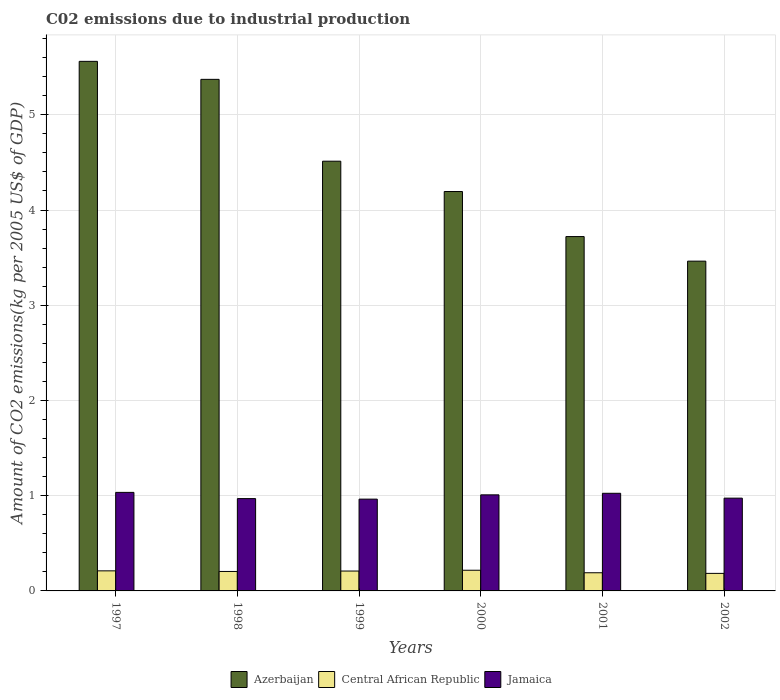Are the number of bars per tick equal to the number of legend labels?
Make the answer very short. Yes. How many bars are there on the 1st tick from the right?
Give a very brief answer. 3. What is the label of the 2nd group of bars from the left?
Offer a terse response. 1998. What is the amount of CO2 emitted due to industrial production in Central African Republic in 2000?
Your response must be concise. 0.22. Across all years, what is the maximum amount of CO2 emitted due to industrial production in Azerbaijan?
Give a very brief answer. 5.56. Across all years, what is the minimum amount of CO2 emitted due to industrial production in Jamaica?
Your response must be concise. 0.96. What is the total amount of CO2 emitted due to industrial production in Central African Republic in the graph?
Your response must be concise. 1.22. What is the difference between the amount of CO2 emitted due to industrial production in Jamaica in 2001 and that in 2002?
Make the answer very short. 0.05. What is the difference between the amount of CO2 emitted due to industrial production in Jamaica in 2002 and the amount of CO2 emitted due to industrial production in Central African Republic in 1999?
Provide a succinct answer. 0.77. What is the average amount of CO2 emitted due to industrial production in Central African Republic per year?
Provide a short and direct response. 0.2. In the year 1998, what is the difference between the amount of CO2 emitted due to industrial production in Central African Republic and amount of CO2 emitted due to industrial production in Azerbaijan?
Your answer should be very brief. -5.17. What is the ratio of the amount of CO2 emitted due to industrial production in Jamaica in 1997 to that in 2002?
Your answer should be compact. 1.06. Is the difference between the amount of CO2 emitted due to industrial production in Central African Republic in 2000 and 2002 greater than the difference between the amount of CO2 emitted due to industrial production in Azerbaijan in 2000 and 2002?
Provide a succinct answer. No. What is the difference between the highest and the second highest amount of CO2 emitted due to industrial production in Central African Republic?
Your answer should be very brief. 0.01. What is the difference between the highest and the lowest amount of CO2 emitted due to industrial production in Azerbaijan?
Give a very brief answer. 2.1. Is the sum of the amount of CO2 emitted due to industrial production in Jamaica in 1998 and 1999 greater than the maximum amount of CO2 emitted due to industrial production in Central African Republic across all years?
Your answer should be very brief. Yes. What does the 2nd bar from the left in 2002 represents?
Ensure brevity in your answer.  Central African Republic. What does the 3rd bar from the right in 2001 represents?
Provide a short and direct response. Azerbaijan. How many bars are there?
Your answer should be very brief. 18. Are all the bars in the graph horizontal?
Your answer should be very brief. No. What is the difference between two consecutive major ticks on the Y-axis?
Provide a succinct answer. 1. Are the values on the major ticks of Y-axis written in scientific E-notation?
Give a very brief answer. No. Does the graph contain grids?
Make the answer very short. Yes. Where does the legend appear in the graph?
Give a very brief answer. Bottom center. What is the title of the graph?
Your answer should be compact. C02 emissions due to industrial production. What is the label or title of the Y-axis?
Give a very brief answer. Amount of CO2 emissions(kg per 2005 US$ of GDP). What is the Amount of CO2 emissions(kg per 2005 US$ of GDP) of Azerbaijan in 1997?
Keep it short and to the point. 5.56. What is the Amount of CO2 emissions(kg per 2005 US$ of GDP) of Central African Republic in 1997?
Give a very brief answer. 0.21. What is the Amount of CO2 emissions(kg per 2005 US$ of GDP) in Jamaica in 1997?
Provide a succinct answer. 1.03. What is the Amount of CO2 emissions(kg per 2005 US$ of GDP) of Azerbaijan in 1998?
Provide a short and direct response. 5.37. What is the Amount of CO2 emissions(kg per 2005 US$ of GDP) in Central African Republic in 1998?
Keep it short and to the point. 0.2. What is the Amount of CO2 emissions(kg per 2005 US$ of GDP) of Jamaica in 1998?
Give a very brief answer. 0.97. What is the Amount of CO2 emissions(kg per 2005 US$ of GDP) of Azerbaijan in 1999?
Make the answer very short. 4.51. What is the Amount of CO2 emissions(kg per 2005 US$ of GDP) in Central African Republic in 1999?
Your response must be concise. 0.21. What is the Amount of CO2 emissions(kg per 2005 US$ of GDP) in Jamaica in 1999?
Make the answer very short. 0.96. What is the Amount of CO2 emissions(kg per 2005 US$ of GDP) in Azerbaijan in 2000?
Provide a succinct answer. 4.19. What is the Amount of CO2 emissions(kg per 2005 US$ of GDP) in Central African Republic in 2000?
Your answer should be compact. 0.22. What is the Amount of CO2 emissions(kg per 2005 US$ of GDP) in Jamaica in 2000?
Offer a very short reply. 1.01. What is the Amount of CO2 emissions(kg per 2005 US$ of GDP) in Azerbaijan in 2001?
Offer a terse response. 3.72. What is the Amount of CO2 emissions(kg per 2005 US$ of GDP) of Central African Republic in 2001?
Make the answer very short. 0.19. What is the Amount of CO2 emissions(kg per 2005 US$ of GDP) in Jamaica in 2001?
Provide a short and direct response. 1.03. What is the Amount of CO2 emissions(kg per 2005 US$ of GDP) in Azerbaijan in 2002?
Give a very brief answer. 3.46. What is the Amount of CO2 emissions(kg per 2005 US$ of GDP) in Central African Republic in 2002?
Your response must be concise. 0.18. What is the Amount of CO2 emissions(kg per 2005 US$ of GDP) in Jamaica in 2002?
Provide a succinct answer. 0.97. Across all years, what is the maximum Amount of CO2 emissions(kg per 2005 US$ of GDP) of Azerbaijan?
Your response must be concise. 5.56. Across all years, what is the maximum Amount of CO2 emissions(kg per 2005 US$ of GDP) in Central African Republic?
Ensure brevity in your answer.  0.22. Across all years, what is the maximum Amount of CO2 emissions(kg per 2005 US$ of GDP) of Jamaica?
Your answer should be very brief. 1.03. Across all years, what is the minimum Amount of CO2 emissions(kg per 2005 US$ of GDP) of Azerbaijan?
Offer a terse response. 3.46. Across all years, what is the minimum Amount of CO2 emissions(kg per 2005 US$ of GDP) in Central African Republic?
Ensure brevity in your answer.  0.18. Across all years, what is the minimum Amount of CO2 emissions(kg per 2005 US$ of GDP) of Jamaica?
Your answer should be compact. 0.96. What is the total Amount of CO2 emissions(kg per 2005 US$ of GDP) in Azerbaijan in the graph?
Your response must be concise. 26.83. What is the total Amount of CO2 emissions(kg per 2005 US$ of GDP) in Central African Republic in the graph?
Your response must be concise. 1.22. What is the total Amount of CO2 emissions(kg per 2005 US$ of GDP) of Jamaica in the graph?
Your response must be concise. 5.98. What is the difference between the Amount of CO2 emissions(kg per 2005 US$ of GDP) in Azerbaijan in 1997 and that in 1998?
Make the answer very short. 0.19. What is the difference between the Amount of CO2 emissions(kg per 2005 US$ of GDP) of Central African Republic in 1997 and that in 1998?
Provide a short and direct response. 0.01. What is the difference between the Amount of CO2 emissions(kg per 2005 US$ of GDP) in Jamaica in 1997 and that in 1998?
Offer a very short reply. 0.07. What is the difference between the Amount of CO2 emissions(kg per 2005 US$ of GDP) in Azerbaijan in 1997 and that in 1999?
Provide a succinct answer. 1.05. What is the difference between the Amount of CO2 emissions(kg per 2005 US$ of GDP) in Central African Republic in 1997 and that in 1999?
Make the answer very short. 0. What is the difference between the Amount of CO2 emissions(kg per 2005 US$ of GDP) in Jamaica in 1997 and that in 1999?
Keep it short and to the point. 0.07. What is the difference between the Amount of CO2 emissions(kg per 2005 US$ of GDP) of Azerbaijan in 1997 and that in 2000?
Make the answer very short. 1.37. What is the difference between the Amount of CO2 emissions(kg per 2005 US$ of GDP) in Central African Republic in 1997 and that in 2000?
Provide a succinct answer. -0.01. What is the difference between the Amount of CO2 emissions(kg per 2005 US$ of GDP) of Jamaica in 1997 and that in 2000?
Your answer should be compact. 0.03. What is the difference between the Amount of CO2 emissions(kg per 2005 US$ of GDP) in Azerbaijan in 1997 and that in 2001?
Ensure brevity in your answer.  1.84. What is the difference between the Amount of CO2 emissions(kg per 2005 US$ of GDP) of Jamaica in 1997 and that in 2001?
Ensure brevity in your answer.  0.01. What is the difference between the Amount of CO2 emissions(kg per 2005 US$ of GDP) in Azerbaijan in 1997 and that in 2002?
Your answer should be compact. 2.1. What is the difference between the Amount of CO2 emissions(kg per 2005 US$ of GDP) in Central African Republic in 1997 and that in 2002?
Make the answer very short. 0.03. What is the difference between the Amount of CO2 emissions(kg per 2005 US$ of GDP) of Jamaica in 1997 and that in 2002?
Your answer should be compact. 0.06. What is the difference between the Amount of CO2 emissions(kg per 2005 US$ of GDP) in Azerbaijan in 1998 and that in 1999?
Offer a terse response. 0.86. What is the difference between the Amount of CO2 emissions(kg per 2005 US$ of GDP) of Central African Republic in 1998 and that in 1999?
Offer a very short reply. -0. What is the difference between the Amount of CO2 emissions(kg per 2005 US$ of GDP) in Jamaica in 1998 and that in 1999?
Offer a very short reply. 0.01. What is the difference between the Amount of CO2 emissions(kg per 2005 US$ of GDP) of Azerbaijan in 1998 and that in 2000?
Your response must be concise. 1.18. What is the difference between the Amount of CO2 emissions(kg per 2005 US$ of GDP) in Central African Republic in 1998 and that in 2000?
Your answer should be very brief. -0.01. What is the difference between the Amount of CO2 emissions(kg per 2005 US$ of GDP) in Jamaica in 1998 and that in 2000?
Keep it short and to the point. -0.04. What is the difference between the Amount of CO2 emissions(kg per 2005 US$ of GDP) in Azerbaijan in 1998 and that in 2001?
Provide a succinct answer. 1.65. What is the difference between the Amount of CO2 emissions(kg per 2005 US$ of GDP) of Central African Republic in 1998 and that in 2001?
Offer a very short reply. 0.01. What is the difference between the Amount of CO2 emissions(kg per 2005 US$ of GDP) in Jamaica in 1998 and that in 2001?
Ensure brevity in your answer.  -0.06. What is the difference between the Amount of CO2 emissions(kg per 2005 US$ of GDP) in Azerbaijan in 1998 and that in 2002?
Offer a very short reply. 1.91. What is the difference between the Amount of CO2 emissions(kg per 2005 US$ of GDP) of Central African Republic in 1998 and that in 2002?
Provide a succinct answer. 0.02. What is the difference between the Amount of CO2 emissions(kg per 2005 US$ of GDP) in Jamaica in 1998 and that in 2002?
Ensure brevity in your answer.  -0. What is the difference between the Amount of CO2 emissions(kg per 2005 US$ of GDP) of Azerbaijan in 1999 and that in 2000?
Ensure brevity in your answer.  0.32. What is the difference between the Amount of CO2 emissions(kg per 2005 US$ of GDP) in Central African Republic in 1999 and that in 2000?
Offer a terse response. -0.01. What is the difference between the Amount of CO2 emissions(kg per 2005 US$ of GDP) of Jamaica in 1999 and that in 2000?
Your response must be concise. -0.04. What is the difference between the Amount of CO2 emissions(kg per 2005 US$ of GDP) in Azerbaijan in 1999 and that in 2001?
Offer a very short reply. 0.79. What is the difference between the Amount of CO2 emissions(kg per 2005 US$ of GDP) of Central African Republic in 1999 and that in 2001?
Keep it short and to the point. 0.02. What is the difference between the Amount of CO2 emissions(kg per 2005 US$ of GDP) of Jamaica in 1999 and that in 2001?
Offer a very short reply. -0.06. What is the difference between the Amount of CO2 emissions(kg per 2005 US$ of GDP) in Azerbaijan in 1999 and that in 2002?
Keep it short and to the point. 1.05. What is the difference between the Amount of CO2 emissions(kg per 2005 US$ of GDP) in Central African Republic in 1999 and that in 2002?
Your answer should be compact. 0.02. What is the difference between the Amount of CO2 emissions(kg per 2005 US$ of GDP) in Jamaica in 1999 and that in 2002?
Offer a very short reply. -0.01. What is the difference between the Amount of CO2 emissions(kg per 2005 US$ of GDP) of Azerbaijan in 2000 and that in 2001?
Provide a succinct answer. 0.47. What is the difference between the Amount of CO2 emissions(kg per 2005 US$ of GDP) in Central African Republic in 2000 and that in 2001?
Give a very brief answer. 0.03. What is the difference between the Amount of CO2 emissions(kg per 2005 US$ of GDP) of Jamaica in 2000 and that in 2001?
Your answer should be very brief. -0.02. What is the difference between the Amount of CO2 emissions(kg per 2005 US$ of GDP) of Azerbaijan in 2000 and that in 2002?
Ensure brevity in your answer.  0.73. What is the difference between the Amount of CO2 emissions(kg per 2005 US$ of GDP) in Central African Republic in 2000 and that in 2002?
Your answer should be compact. 0.03. What is the difference between the Amount of CO2 emissions(kg per 2005 US$ of GDP) of Jamaica in 2000 and that in 2002?
Offer a terse response. 0.03. What is the difference between the Amount of CO2 emissions(kg per 2005 US$ of GDP) in Azerbaijan in 2001 and that in 2002?
Offer a terse response. 0.26. What is the difference between the Amount of CO2 emissions(kg per 2005 US$ of GDP) in Central African Republic in 2001 and that in 2002?
Keep it short and to the point. 0.01. What is the difference between the Amount of CO2 emissions(kg per 2005 US$ of GDP) of Jamaica in 2001 and that in 2002?
Make the answer very short. 0.05. What is the difference between the Amount of CO2 emissions(kg per 2005 US$ of GDP) in Azerbaijan in 1997 and the Amount of CO2 emissions(kg per 2005 US$ of GDP) in Central African Republic in 1998?
Your response must be concise. 5.36. What is the difference between the Amount of CO2 emissions(kg per 2005 US$ of GDP) in Azerbaijan in 1997 and the Amount of CO2 emissions(kg per 2005 US$ of GDP) in Jamaica in 1998?
Your answer should be very brief. 4.59. What is the difference between the Amount of CO2 emissions(kg per 2005 US$ of GDP) in Central African Republic in 1997 and the Amount of CO2 emissions(kg per 2005 US$ of GDP) in Jamaica in 1998?
Provide a short and direct response. -0.76. What is the difference between the Amount of CO2 emissions(kg per 2005 US$ of GDP) in Azerbaijan in 1997 and the Amount of CO2 emissions(kg per 2005 US$ of GDP) in Central African Republic in 1999?
Offer a terse response. 5.35. What is the difference between the Amount of CO2 emissions(kg per 2005 US$ of GDP) in Azerbaijan in 1997 and the Amount of CO2 emissions(kg per 2005 US$ of GDP) in Jamaica in 1999?
Provide a short and direct response. 4.6. What is the difference between the Amount of CO2 emissions(kg per 2005 US$ of GDP) in Central African Republic in 1997 and the Amount of CO2 emissions(kg per 2005 US$ of GDP) in Jamaica in 1999?
Keep it short and to the point. -0.75. What is the difference between the Amount of CO2 emissions(kg per 2005 US$ of GDP) of Azerbaijan in 1997 and the Amount of CO2 emissions(kg per 2005 US$ of GDP) of Central African Republic in 2000?
Make the answer very short. 5.34. What is the difference between the Amount of CO2 emissions(kg per 2005 US$ of GDP) of Azerbaijan in 1997 and the Amount of CO2 emissions(kg per 2005 US$ of GDP) of Jamaica in 2000?
Provide a succinct answer. 4.55. What is the difference between the Amount of CO2 emissions(kg per 2005 US$ of GDP) in Central African Republic in 1997 and the Amount of CO2 emissions(kg per 2005 US$ of GDP) in Jamaica in 2000?
Ensure brevity in your answer.  -0.8. What is the difference between the Amount of CO2 emissions(kg per 2005 US$ of GDP) of Azerbaijan in 1997 and the Amount of CO2 emissions(kg per 2005 US$ of GDP) of Central African Republic in 2001?
Provide a short and direct response. 5.37. What is the difference between the Amount of CO2 emissions(kg per 2005 US$ of GDP) of Azerbaijan in 1997 and the Amount of CO2 emissions(kg per 2005 US$ of GDP) of Jamaica in 2001?
Make the answer very short. 4.54. What is the difference between the Amount of CO2 emissions(kg per 2005 US$ of GDP) in Central African Republic in 1997 and the Amount of CO2 emissions(kg per 2005 US$ of GDP) in Jamaica in 2001?
Keep it short and to the point. -0.81. What is the difference between the Amount of CO2 emissions(kg per 2005 US$ of GDP) in Azerbaijan in 1997 and the Amount of CO2 emissions(kg per 2005 US$ of GDP) in Central African Republic in 2002?
Your answer should be compact. 5.38. What is the difference between the Amount of CO2 emissions(kg per 2005 US$ of GDP) in Azerbaijan in 1997 and the Amount of CO2 emissions(kg per 2005 US$ of GDP) in Jamaica in 2002?
Offer a very short reply. 4.59. What is the difference between the Amount of CO2 emissions(kg per 2005 US$ of GDP) in Central African Republic in 1997 and the Amount of CO2 emissions(kg per 2005 US$ of GDP) in Jamaica in 2002?
Your answer should be compact. -0.76. What is the difference between the Amount of CO2 emissions(kg per 2005 US$ of GDP) of Azerbaijan in 1998 and the Amount of CO2 emissions(kg per 2005 US$ of GDP) of Central African Republic in 1999?
Provide a short and direct response. 5.16. What is the difference between the Amount of CO2 emissions(kg per 2005 US$ of GDP) of Azerbaijan in 1998 and the Amount of CO2 emissions(kg per 2005 US$ of GDP) of Jamaica in 1999?
Offer a very short reply. 4.41. What is the difference between the Amount of CO2 emissions(kg per 2005 US$ of GDP) in Central African Republic in 1998 and the Amount of CO2 emissions(kg per 2005 US$ of GDP) in Jamaica in 1999?
Make the answer very short. -0.76. What is the difference between the Amount of CO2 emissions(kg per 2005 US$ of GDP) of Azerbaijan in 1998 and the Amount of CO2 emissions(kg per 2005 US$ of GDP) of Central African Republic in 2000?
Provide a short and direct response. 5.16. What is the difference between the Amount of CO2 emissions(kg per 2005 US$ of GDP) in Azerbaijan in 1998 and the Amount of CO2 emissions(kg per 2005 US$ of GDP) in Jamaica in 2000?
Your answer should be compact. 4.36. What is the difference between the Amount of CO2 emissions(kg per 2005 US$ of GDP) in Central African Republic in 1998 and the Amount of CO2 emissions(kg per 2005 US$ of GDP) in Jamaica in 2000?
Offer a terse response. -0.8. What is the difference between the Amount of CO2 emissions(kg per 2005 US$ of GDP) of Azerbaijan in 1998 and the Amount of CO2 emissions(kg per 2005 US$ of GDP) of Central African Republic in 2001?
Make the answer very short. 5.18. What is the difference between the Amount of CO2 emissions(kg per 2005 US$ of GDP) in Azerbaijan in 1998 and the Amount of CO2 emissions(kg per 2005 US$ of GDP) in Jamaica in 2001?
Your response must be concise. 4.35. What is the difference between the Amount of CO2 emissions(kg per 2005 US$ of GDP) of Central African Republic in 1998 and the Amount of CO2 emissions(kg per 2005 US$ of GDP) of Jamaica in 2001?
Give a very brief answer. -0.82. What is the difference between the Amount of CO2 emissions(kg per 2005 US$ of GDP) in Azerbaijan in 1998 and the Amount of CO2 emissions(kg per 2005 US$ of GDP) in Central African Republic in 2002?
Provide a short and direct response. 5.19. What is the difference between the Amount of CO2 emissions(kg per 2005 US$ of GDP) of Azerbaijan in 1998 and the Amount of CO2 emissions(kg per 2005 US$ of GDP) of Jamaica in 2002?
Keep it short and to the point. 4.4. What is the difference between the Amount of CO2 emissions(kg per 2005 US$ of GDP) of Central African Republic in 1998 and the Amount of CO2 emissions(kg per 2005 US$ of GDP) of Jamaica in 2002?
Offer a terse response. -0.77. What is the difference between the Amount of CO2 emissions(kg per 2005 US$ of GDP) of Azerbaijan in 1999 and the Amount of CO2 emissions(kg per 2005 US$ of GDP) of Central African Republic in 2000?
Your answer should be very brief. 4.3. What is the difference between the Amount of CO2 emissions(kg per 2005 US$ of GDP) in Azerbaijan in 1999 and the Amount of CO2 emissions(kg per 2005 US$ of GDP) in Jamaica in 2000?
Give a very brief answer. 3.5. What is the difference between the Amount of CO2 emissions(kg per 2005 US$ of GDP) of Central African Republic in 1999 and the Amount of CO2 emissions(kg per 2005 US$ of GDP) of Jamaica in 2000?
Offer a terse response. -0.8. What is the difference between the Amount of CO2 emissions(kg per 2005 US$ of GDP) in Azerbaijan in 1999 and the Amount of CO2 emissions(kg per 2005 US$ of GDP) in Central African Republic in 2001?
Your answer should be compact. 4.32. What is the difference between the Amount of CO2 emissions(kg per 2005 US$ of GDP) of Azerbaijan in 1999 and the Amount of CO2 emissions(kg per 2005 US$ of GDP) of Jamaica in 2001?
Provide a short and direct response. 3.49. What is the difference between the Amount of CO2 emissions(kg per 2005 US$ of GDP) in Central African Republic in 1999 and the Amount of CO2 emissions(kg per 2005 US$ of GDP) in Jamaica in 2001?
Keep it short and to the point. -0.82. What is the difference between the Amount of CO2 emissions(kg per 2005 US$ of GDP) in Azerbaijan in 1999 and the Amount of CO2 emissions(kg per 2005 US$ of GDP) in Central African Republic in 2002?
Keep it short and to the point. 4.33. What is the difference between the Amount of CO2 emissions(kg per 2005 US$ of GDP) of Azerbaijan in 1999 and the Amount of CO2 emissions(kg per 2005 US$ of GDP) of Jamaica in 2002?
Give a very brief answer. 3.54. What is the difference between the Amount of CO2 emissions(kg per 2005 US$ of GDP) in Central African Republic in 1999 and the Amount of CO2 emissions(kg per 2005 US$ of GDP) in Jamaica in 2002?
Keep it short and to the point. -0.77. What is the difference between the Amount of CO2 emissions(kg per 2005 US$ of GDP) of Azerbaijan in 2000 and the Amount of CO2 emissions(kg per 2005 US$ of GDP) of Central African Republic in 2001?
Make the answer very short. 4. What is the difference between the Amount of CO2 emissions(kg per 2005 US$ of GDP) of Azerbaijan in 2000 and the Amount of CO2 emissions(kg per 2005 US$ of GDP) of Jamaica in 2001?
Make the answer very short. 3.17. What is the difference between the Amount of CO2 emissions(kg per 2005 US$ of GDP) of Central African Republic in 2000 and the Amount of CO2 emissions(kg per 2005 US$ of GDP) of Jamaica in 2001?
Give a very brief answer. -0.81. What is the difference between the Amount of CO2 emissions(kg per 2005 US$ of GDP) of Azerbaijan in 2000 and the Amount of CO2 emissions(kg per 2005 US$ of GDP) of Central African Republic in 2002?
Your response must be concise. 4.01. What is the difference between the Amount of CO2 emissions(kg per 2005 US$ of GDP) in Azerbaijan in 2000 and the Amount of CO2 emissions(kg per 2005 US$ of GDP) in Jamaica in 2002?
Provide a succinct answer. 3.22. What is the difference between the Amount of CO2 emissions(kg per 2005 US$ of GDP) in Central African Republic in 2000 and the Amount of CO2 emissions(kg per 2005 US$ of GDP) in Jamaica in 2002?
Offer a terse response. -0.76. What is the difference between the Amount of CO2 emissions(kg per 2005 US$ of GDP) of Azerbaijan in 2001 and the Amount of CO2 emissions(kg per 2005 US$ of GDP) of Central African Republic in 2002?
Offer a very short reply. 3.54. What is the difference between the Amount of CO2 emissions(kg per 2005 US$ of GDP) of Azerbaijan in 2001 and the Amount of CO2 emissions(kg per 2005 US$ of GDP) of Jamaica in 2002?
Your answer should be compact. 2.75. What is the difference between the Amount of CO2 emissions(kg per 2005 US$ of GDP) of Central African Republic in 2001 and the Amount of CO2 emissions(kg per 2005 US$ of GDP) of Jamaica in 2002?
Your answer should be compact. -0.78. What is the average Amount of CO2 emissions(kg per 2005 US$ of GDP) of Azerbaijan per year?
Keep it short and to the point. 4.47. What is the average Amount of CO2 emissions(kg per 2005 US$ of GDP) of Central African Republic per year?
Your answer should be compact. 0.2. In the year 1997, what is the difference between the Amount of CO2 emissions(kg per 2005 US$ of GDP) of Azerbaijan and Amount of CO2 emissions(kg per 2005 US$ of GDP) of Central African Republic?
Provide a succinct answer. 5.35. In the year 1997, what is the difference between the Amount of CO2 emissions(kg per 2005 US$ of GDP) in Azerbaijan and Amount of CO2 emissions(kg per 2005 US$ of GDP) in Jamaica?
Your answer should be very brief. 4.53. In the year 1997, what is the difference between the Amount of CO2 emissions(kg per 2005 US$ of GDP) in Central African Republic and Amount of CO2 emissions(kg per 2005 US$ of GDP) in Jamaica?
Provide a short and direct response. -0.82. In the year 1998, what is the difference between the Amount of CO2 emissions(kg per 2005 US$ of GDP) in Azerbaijan and Amount of CO2 emissions(kg per 2005 US$ of GDP) in Central African Republic?
Give a very brief answer. 5.17. In the year 1998, what is the difference between the Amount of CO2 emissions(kg per 2005 US$ of GDP) in Azerbaijan and Amount of CO2 emissions(kg per 2005 US$ of GDP) in Jamaica?
Offer a very short reply. 4.4. In the year 1998, what is the difference between the Amount of CO2 emissions(kg per 2005 US$ of GDP) in Central African Republic and Amount of CO2 emissions(kg per 2005 US$ of GDP) in Jamaica?
Offer a terse response. -0.77. In the year 1999, what is the difference between the Amount of CO2 emissions(kg per 2005 US$ of GDP) in Azerbaijan and Amount of CO2 emissions(kg per 2005 US$ of GDP) in Central African Republic?
Ensure brevity in your answer.  4.3. In the year 1999, what is the difference between the Amount of CO2 emissions(kg per 2005 US$ of GDP) in Azerbaijan and Amount of CO2 emissions(kg per 2005 US$ of GDP) in Jamaica?
Your response must be concise. 3.55. In the year 1999, what is the difference between the Amount of CO2 emissions(kg per 2005 US$ of GDP) in Central African Republic and Amount of CO2 emissions(kg per 2005 US$ of GDP) in Jamaica?
Your answer should be very brief. -0.76. In the year 2000, what is the difference between the Amount of CO2 emissions(kg per 2005 US$ of GDP) of Azerbaijan and Amount of CO2 emissions(kg per 2005 US$ of GDP) of Central African Republic?
Ensure brevity in your answer.  3.98. In the year 2000, what is the difference between the Amount of CO2 emissions(kg per 2005 US$ of GDP) of Azerbaijan and Amount of CO2 emissions(kg per 2005 US$ of GDP) of Jamaica?
Make the answer very short. 3.19. In the year 2000, what is the difference between the Amount of CO2 emissions(kg per 2005 US$ of GDP) in Central African Republic and Amount of CO2 emissions(kg per 2005 US$ of GDP) in Jamaica?
Offer a very short reply. -0.79. In the year 2001, what is the difference between the Amount of CO2 emissions(kg per 2005 US$ of GDP) in Azerbaijan and Amount of CO2 emissions(kg per 2005 US$ of GDP) in Central African Republic?
Provide a short and direct response. 3.53. In the year 2001, what is the difference between the Amount of CO2 emissions(kg per 2005 US$ of GDP) of Azerbaijan and Amount of CO2 emissions(kg per 2005 US$ of GDP) of Jamaica?
Keep it short and to the point. 2.7. In the year 2001, what is the difference between the Amount of CO2 emissions(kg per 2005 US$ of GDP) in Central African Republic and Amount of CO2 emissions(kg per 2005 US$ of GDP) in Jamaica?
Your response must be concise. -0.83. In the year 2002, what is the difference between the Amount of CO2 emissions(kg per 2005 US$ of GDP) in Azerbaijan and Amount of CO2 emissions(kg per 2005 US$ of GDP) in Central African Republic?
Give a very brief answer. 3.28. In the year 2002, what is the difference between the Amount of CO2 emissions(kg per 2005 US$ of GDP) of Azerbaijan and Amount of CO2 emissions(kg per 2005 US$ of GDP) of Jamaica?
Provide a succinct answer. 2.49. In the year 2002, what is the difference between the Amount of CO2 emissions(kg per 2005 US$ of GDP) in Central African Republic and Amount of CO2 emissions(kg per 2005 US$ of GDP) in Jamaica?
Provide a short and direct response. -0.79. What is the ratio of the Amount of CO2 emissions(kg per 2005 US$ of GDP) of Azerbaijan in 1997 to that in 1998?
Provide a succinct answer. 1.04. What is the ratio of the Amount of CO2 emissions(kg per 2005 US$ of GDP) of Central African Republic in 1997 to that in 1998?
Ensure brevity in your answer.  1.03. What is the ratio of the Amount of CO2 emissions(kg per 2005 US$ of GDP) in Jamaica in 1997 to that in 1998?
Your answer should be very brief. 1.07. What is the ratio of the Amount of CO2 emissions(kg per 2005 US$ of GDP) of Azerbaijan in 1997 to that in 1999?
Make the answer very short. 1.23. What is the ratio of the Amount of CO2 emissions(kg per 2005 US$ of GDP) of Central African Republic in 1997 to that in 1999?
Ensure brevity in your answer.  1.01. What is the ratio of the Amount of CO2 emissions(kg per 2005 US$ of GDP) in Jamaica in 1997 to that in 1999?
Keep it short and to the point. 1.07. What is the ratio of the Amount of CO2 emissions(kg per 2005 US$ of GDP) of Azerbaijan in 1997 to that in 2000?
Your response must be concise. 1.33. What is the ratio of the Amount of CO2 emissions(kg per 2005 US$ of GDP) in Central African Republic in 1997 to that in 2000?
Provide a short and direct response. 0.97. What is the ratio of the Amount of CO2 emissions(kg per 2005 US$ of GDP) of Jamaica in 1997 to that in 2000?
Make the answer very short. 1.03. What is the ratio of the Amount of CO2 emissions(kg per 2005 US$ of GDP) of Azerbaijan in 1997 to that in 2001?
Your answer should be very brief. 1.49. What is the ratio of the Amount of CO2 emissions(kg per 2005 US$ of GDP) of Central African Republic in 1997 to that in 2001?
Provide a short and direct response. 1.1. What is the ratio of the Amount of CO2 emissions(kg per 2005 US$ of GDP) of Jamaica in 1997 to that in 2001?
Keep it short and to the point. 1.01. What is the ratio of the Amount of CO2 emissions(kg per 2005 US$ of GDP) of Azerbaijan in 1997 to that in 2002?
Offer a terse response. 1.61. What is the ratio of the Amount of CO2 emissions(kg per 2005 US$ of GDP) of Central African Republic in 1997 to that in 2002?
Offer a very short reply. 1.14. What is the ratio of the Amount of CO2 emissions(kg per 2005 US$ of GDP) of Jamaica in 1997 to that in 2002?
Your answer should be compact. 1.06. What is the ratio of the Amount of CO2 emissions(kg per 2005 US$ of GDP) of Azerbaijan in 1998 to that in 1999?
Your response must be concise. 1.19. What is the ratio of the Amount of CO2 emissions(kg per 2005 US$ of GDP) of Central African Republic in 1998 to that in 1999?
Provide a short and direct response. 0.98. What is the ratio of the Amount of CO2 emissions(kg per 2005 US$ of GDP) in Jamaica in 1998 to that in 1999?
Keep it short and to the point. 1.01. What is the ratio of the Amount of CO2 emissions(kg per 2005 US$ of GDP) of Azerbaijan in 1998 to that in 2000?
Provide a succinct answer. 1.28. What is the ratio of the Amount of CO2 emissions(kg per 2005 US$ of GDP) of Central African Republic in 1998 to that in 2000?
Offer a very short reply. 0.94. What is the ratio of the Amount of CO2 emissions(kg per 2005 US$ of GDP) in Azerbaijan in 1998 to that in 2001?
Keep it short and to the point. 1.44. What is the ratio of the Amount of CO2 emissions(kg per 2005 US$ of GDP) of Central African Republic in 1998 to that in 2001?
Make the answer very short. 1.07. What is the ratio of the Amount of CO2 emissions(kg per 2005 US$ of GDP) of Jamaica in 1998 to that in 2001?
Give a very brief answer. 0.95. What is the ratio of the Amount of CO2 emissions(kg per 2005 US$ of GDP) of Azerbaijan in 1998 to that in 2002?
Make the answer very short. 1.55. What is the ratio of the Amount of CO2 emissions(kg per 2005 US$ of GDP) of Central African Republic in 1998 to that in 2002?
Your answer should be very brief. 1.11. What is the ratio of the Amount of CO2 emissions(kg per 2005 US$ of GDP) in Azerbaijan in 1999 to that in 2000?
Your answer should be compact. 1.08. What is the ratio of the Amount of CO2 emissions(kg per 2005 US$ of GDP) in Central African Republic in 1999 to that in 2000?
Your answer should be compact. 0.96. What is the ratio of the Amount of CO2 emissions(kg per 2005 US$ of GDP) of Jamaica in 1999 to that in 2000?
Ensure brevity in your answer.  0.96. What is the ratio of the Amount of CO2 emissions(kg per 2005 US$ of GDP) of Azerbaijan in 1999 to that in 2001?
Provide a short and direct response. 1.21. What is the ratio of the Amount of CO2 emissions(kg per 2005 US$ of GDP) of Central African Republic in 1999 to that in 2001?
Your answer should be very brief. 1.09. What is the ratio of the Amount of CO2 emissions(kg per 2005 US$ of GDP) of Jamaica in 1999 to that in 2001?
Ensure brevity in your answer.  0.94. What is the ratio of the Amount of CO2 emissions(kg per 2005 US$ of GDP) in Azerbaijan in 1999 to that in 2002?
Keep it short and to the point. 1.3. What is the ratio of the Amount of CO2 emissions(kg per 2005 US$ of GDP) of Central African Republic in 1999 to that in 2002?
Ensure brevity in your answer.  1.13. What is the ratio of the Amount of CO2 emissions(kg per 2005 US$ of GDP) of Jamaica in 1999 to that in 2002?
Provide a succinct answer. 0.99. What is the ratio of the Amount of CO2 emissions(kg per 2005 US$ of GDP) in Azerbaijan in 2000 to that in 2001?
Make the answer very short. 1.13. What is the ratio of the Amount of CO2 emissions(kg per 2005 US$ of GDP) in Central African Republic in 2000 to that in 2001?
Provide a short and direct response. 1.14. What is the ratio of the Amount of CO2 emissions(kg per 2005 US$ of GDP) of Jamaica in 2000 to that in 2001?
Offer a terse response. 0.98. What is the ratio of the Amount of CO2 emissions(kg per 2005 US$ of GDP) of Azerbaijan in 2000 to that in 2002?
Make the answer very short. 1.21. What is the ratio of the Amount of CO2 emissions(kg per 2005 US$ of GDP) in Central African Republic in 2000 to that in 2002?
Offer a very short reply. 1.18. What is the ratio of the Amount of CO2 emissions(kg per 2005 US$ of GDP) in Jamaica in 2000 to that in 2002?
Your answer should be very brief. 1.04. What is the ratio of the Amount of CO2 emissions(kg per 2005 US$ of GDP) of Azerbaijan in 2001 to that in 2002?
Ensure brevity in your answer.  1.07. What is the ratio of the Amount of CO2 emissions(kg per 2005 US$ of GDP) in Central African Republic in 2001 to that in 2002?
Offer a terse response. 1.04. What is the ratio of the Amount of CO2 emissions(kg per 2005 US$ of GDP) of Jamaica in 2001 to that in 2002?
Offer a very short reply. 1.05. What is the difference between the highest and the second highest Amount of CO2 emissions(kg per 2005 US$ of GDP) of Azerbaijan?
Give a very brief answer. 0.19. What is the difference between the highest and the second highest Amount of CO2 emissions(kg per 2005 US$ of GDP) in Central African Republic?
Provide a succinct answer. 0.01. What is the difference between the highest and the second highest Amount of CO2 emissions(kg per 2005 US$ of GDP) in Jamaica?
Offer a terse response. 0.01. What is the difference between the highest and the lowest Amount of CO2 emissions(kg per 2005 US$ of GDP) of Azerbaijan?
Ensure brevity in your answer.  2.1. What is the difference between the highest and the lowest Amount of CO2 emissions(kg per 2005 US$ of GDP) of Central African Republic?
Your answer should be compact. 0.03. What is the difference between the highest and the lowest Amount of CO2 emissions(kg per 2005 US$ of GDP) of Jamaica?
Provide a short and direct response. 0.07. 